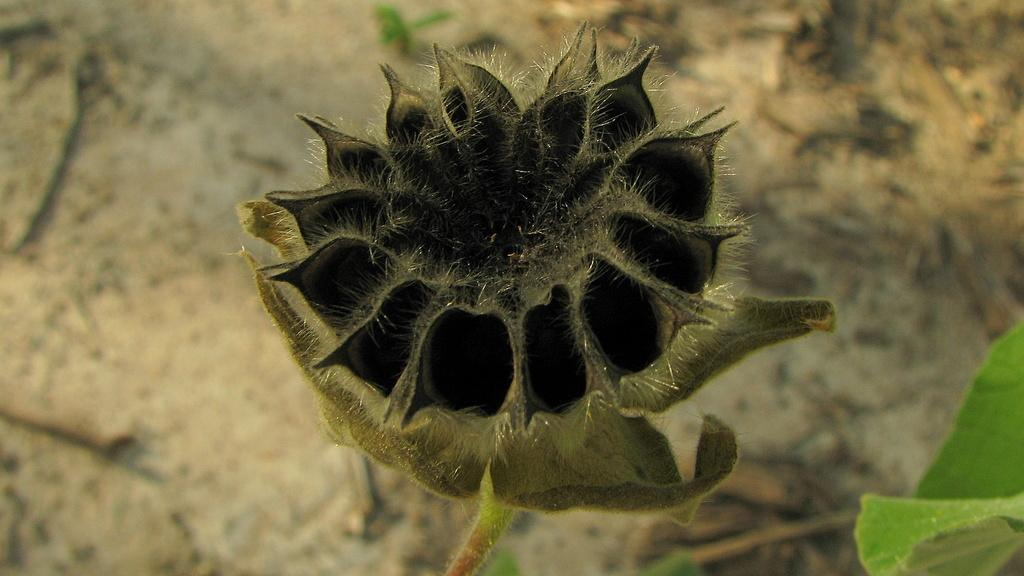What is the main subject of the image? There is a flower in the image. Can you describe any other elements in the image? There is a leaf on the right side of the image. What is the chance of the flower growing into a ship in the image? There is no chance of the flower growing into a ship in the image, as flowers and ships are distinctly different objects. 